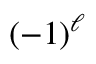Convert formula to latex. <formula><loc_0><loc_0><loc_500><loc_500>{ \left ( { - 1 } \right ) } ^ { \ell }</formula> 